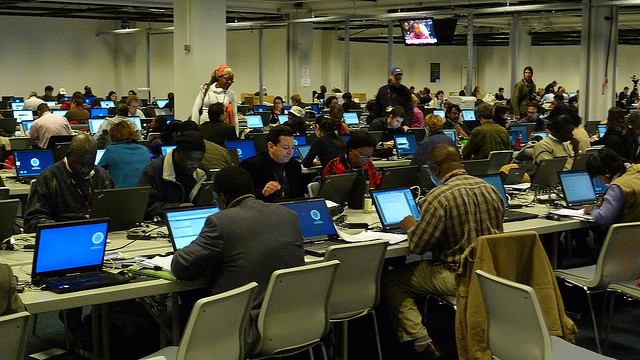What type of event might be taking place here? The setting appears to be a conference or workshop, judging by the numerous individuals typing on laptops and the large projection screen visible in the background. 